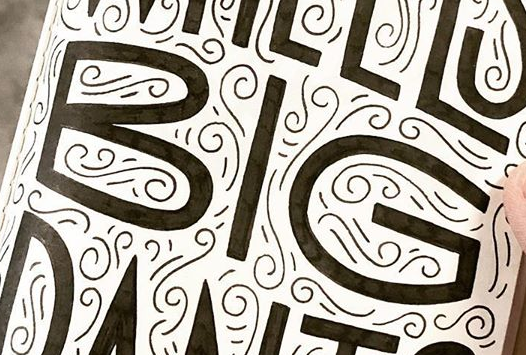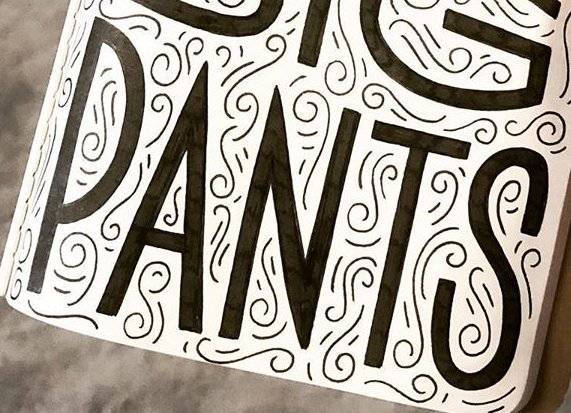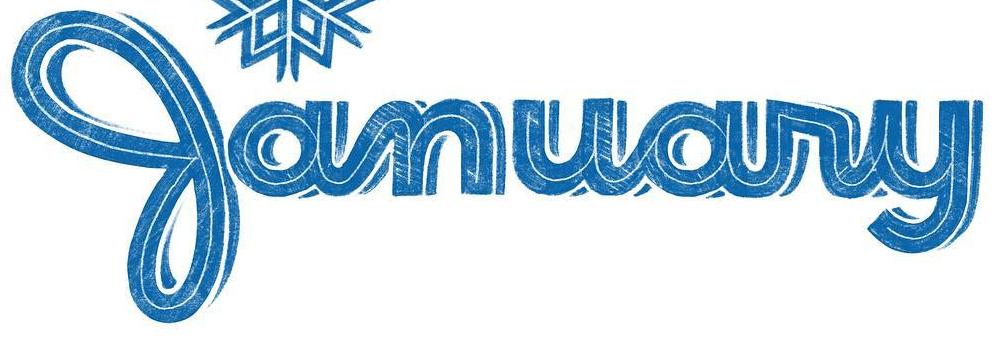What words can you see in these images in sequence, separated by a semicolon? BIG; PANTS; January 